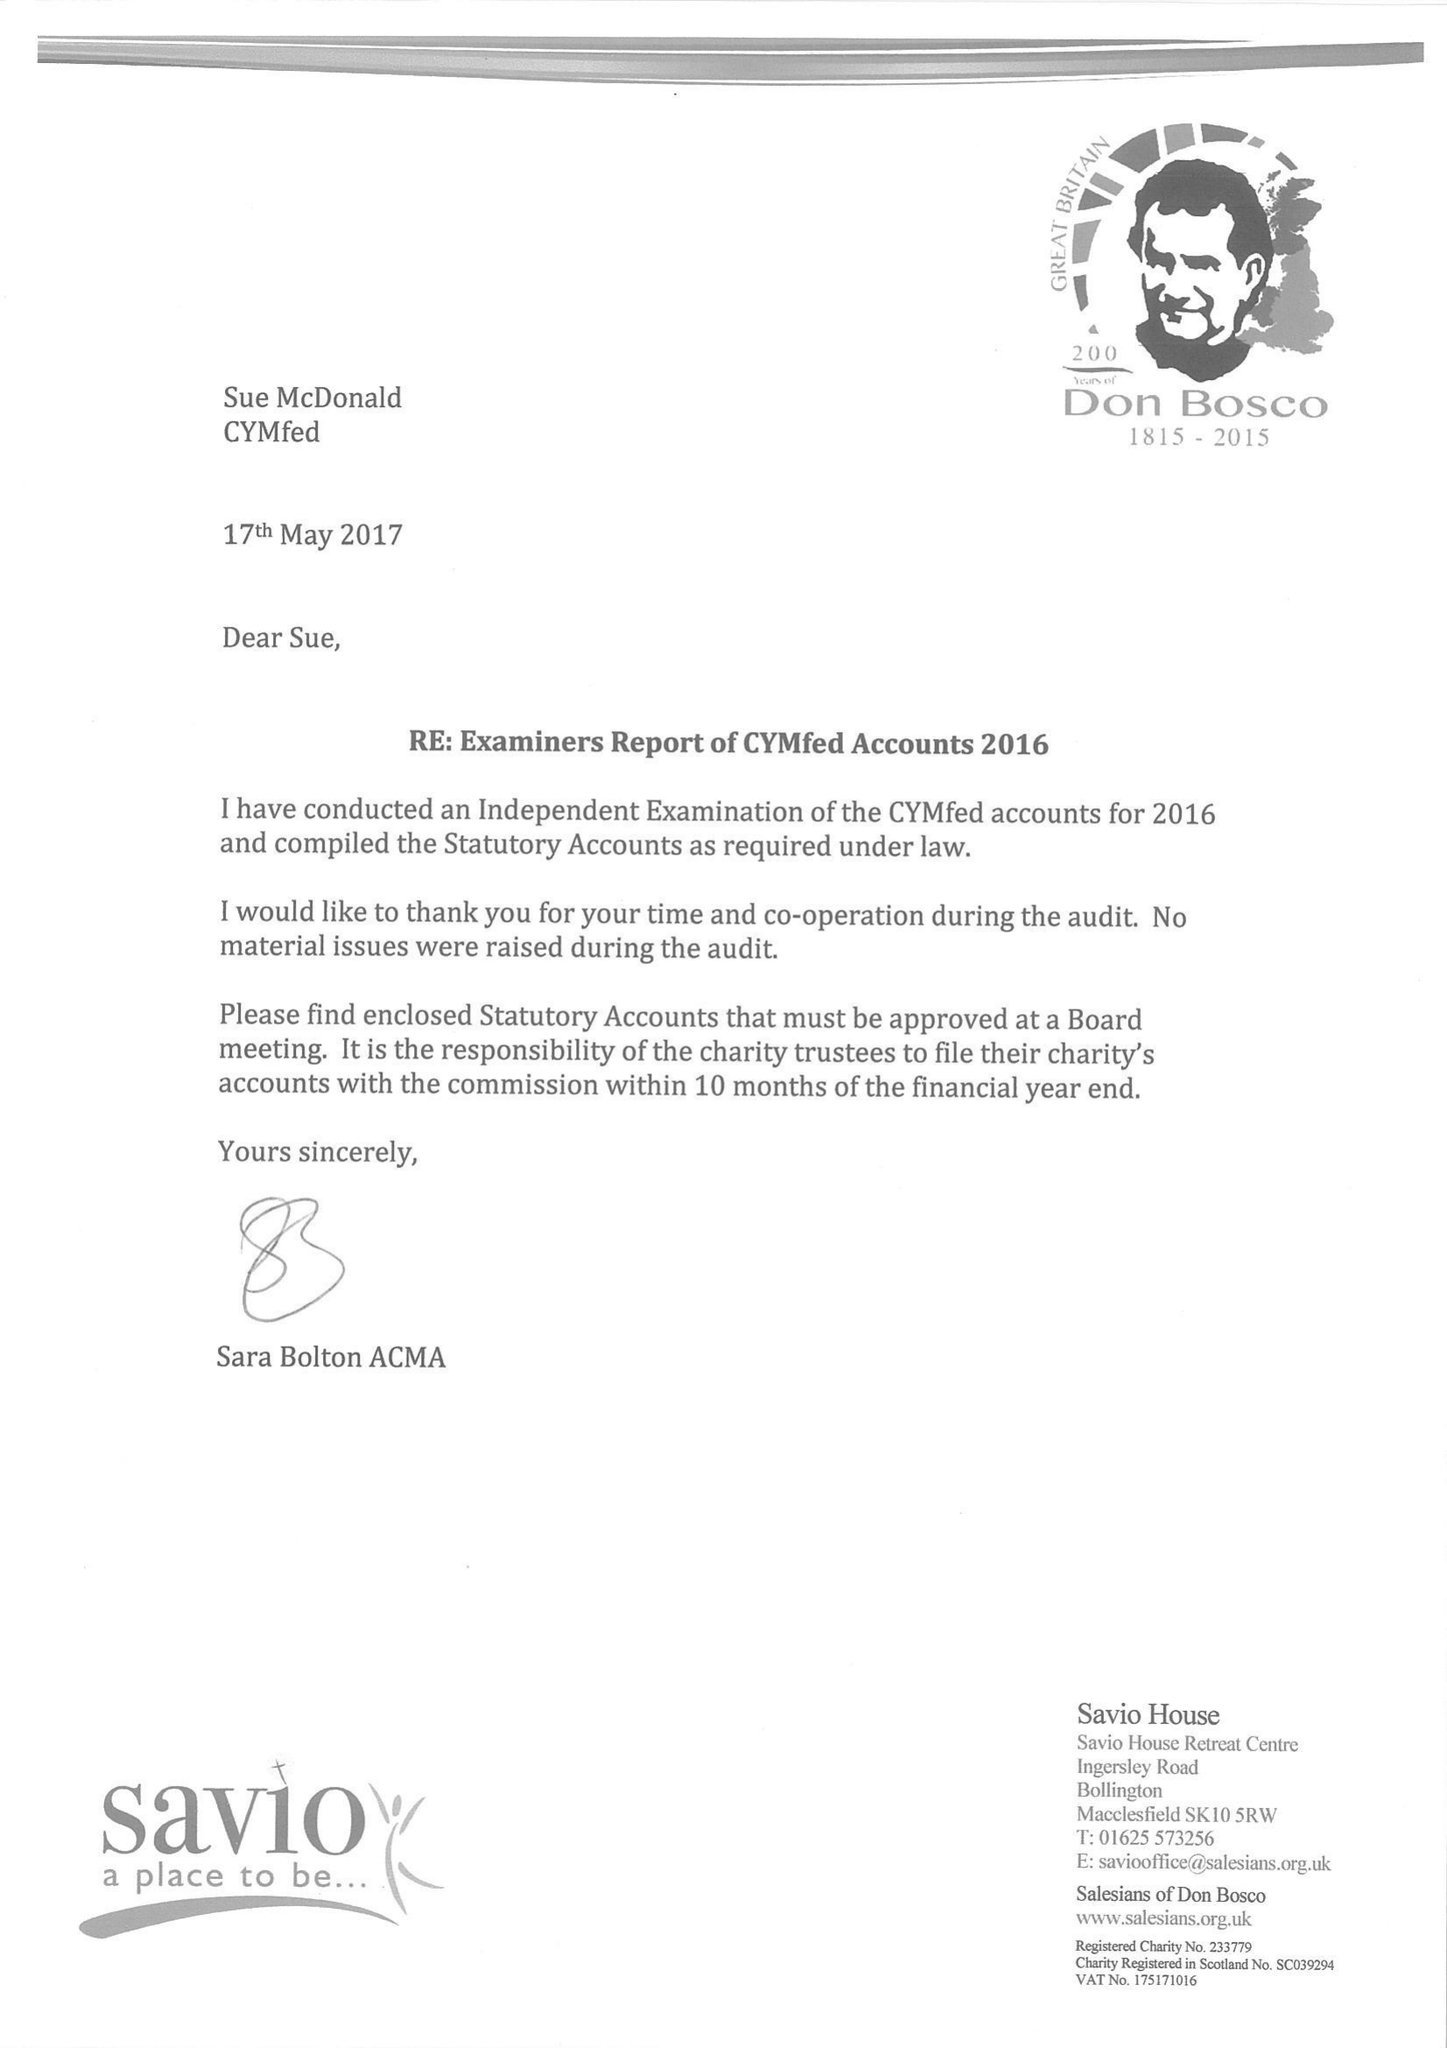What is the value for the income_annually_in_british_pounds?
Answer the question using a single word or phrase. 96899.00 